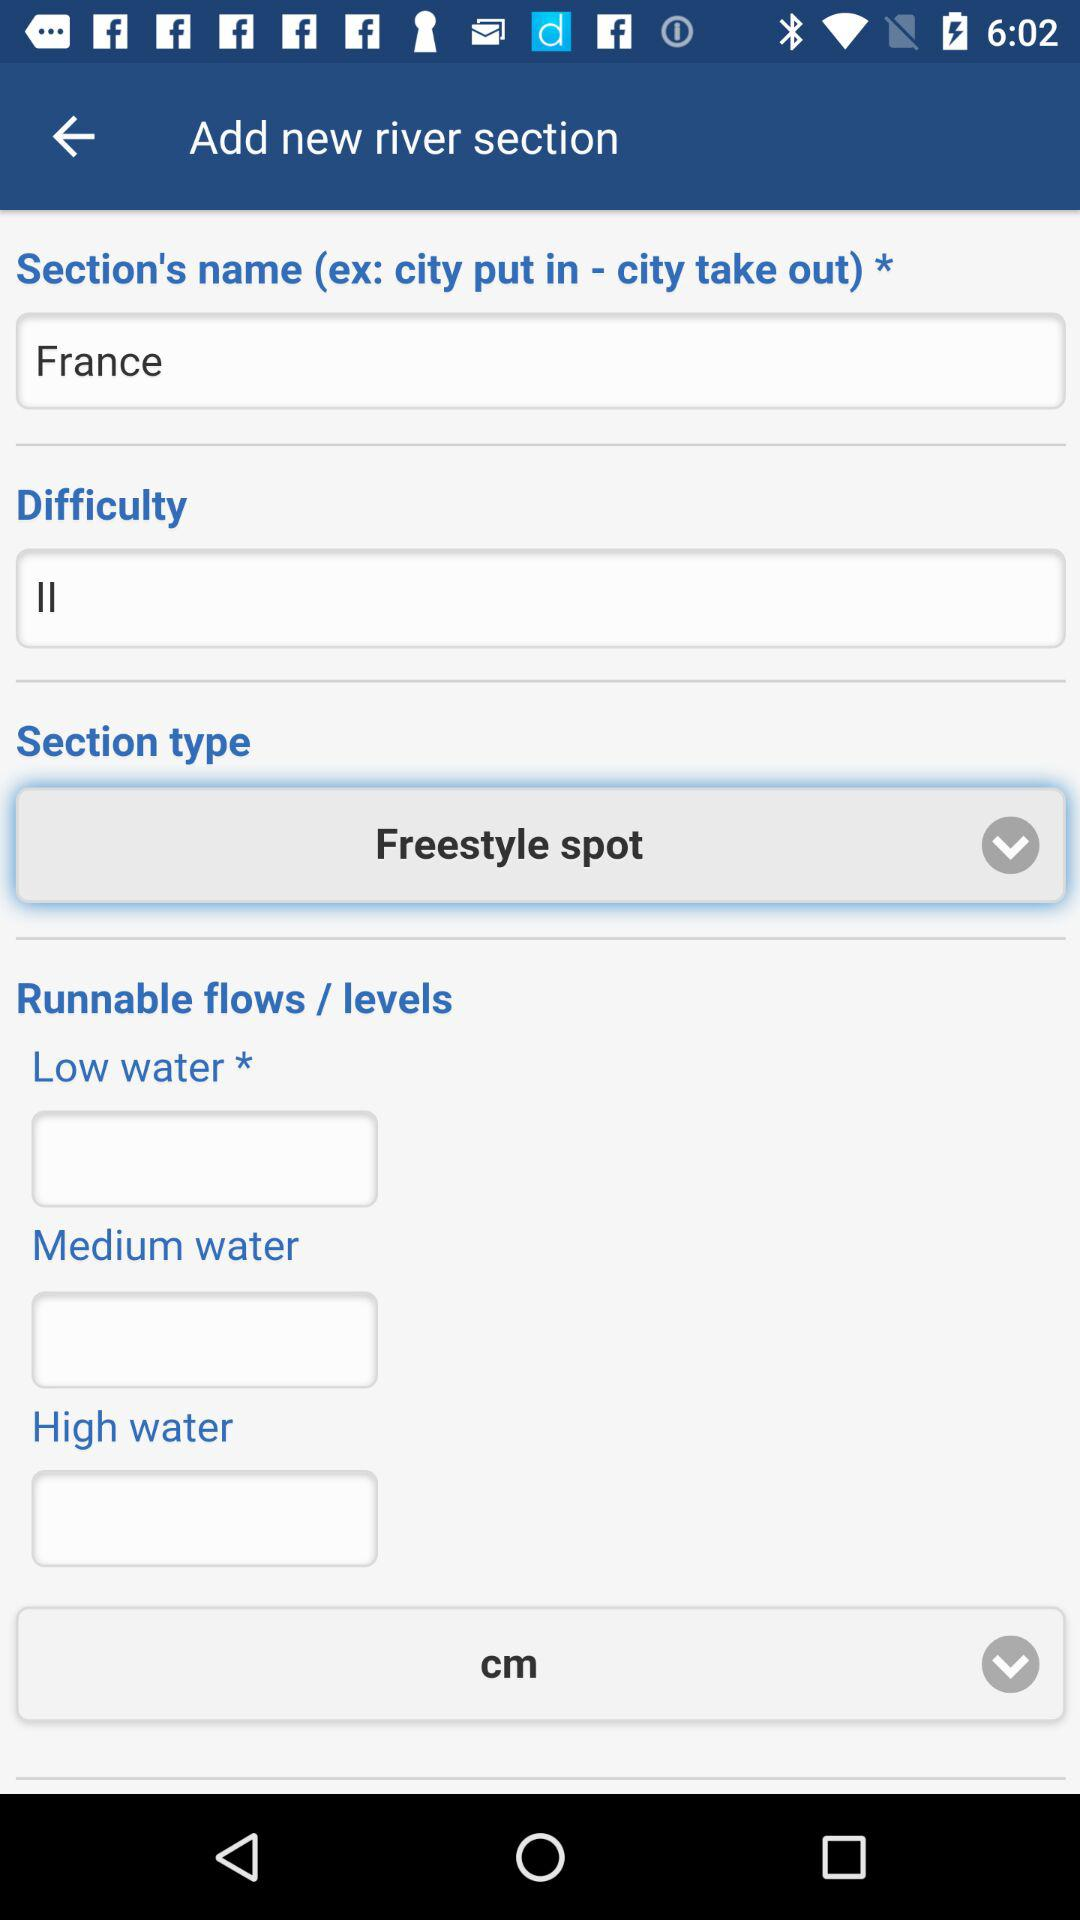What is the "Section's name"? The "Section's name" is France. 